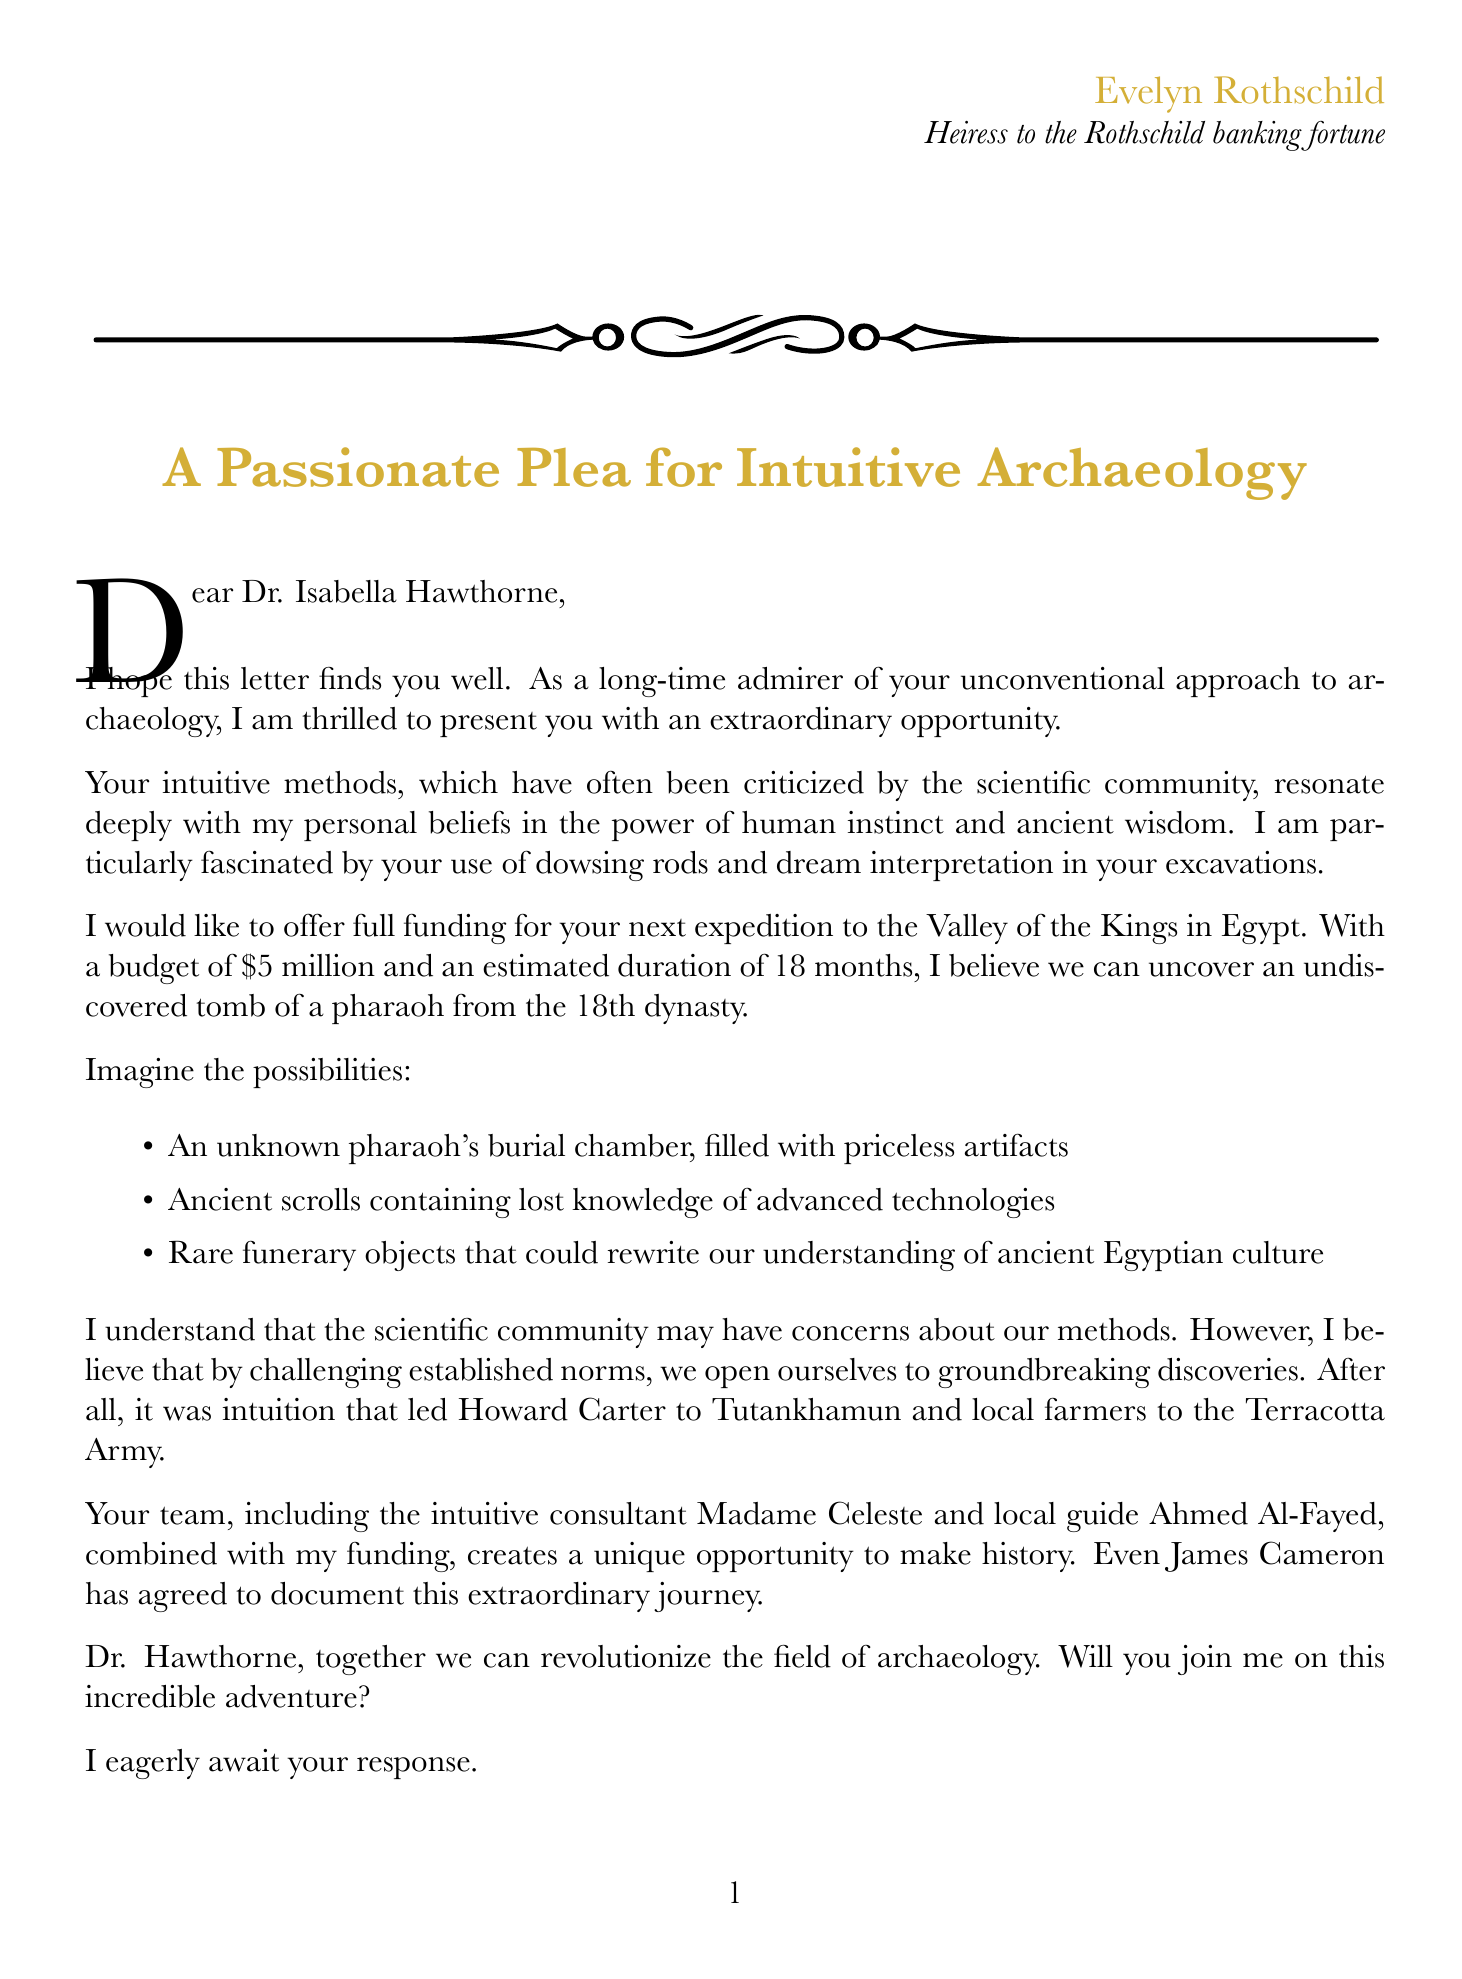what is the name of the donor? The document begins with the name of the donor, Evelyn Rothschild.
Answer: Evelyn Rothschild what is the proposed location for the expedition? The letter specifies the Valley of the Kings as the proposed location for the expedition.
Answer: Valley of the Kings, Egypt what is the budget for the expedition? The letter mentions the funding amount of $5 million for the expedition.
Answer: $5 million how long is the estimated duration of the expedition? The letter states that the estimated duration of the expedition is 18 months.
Answer: 18 months who is the lead archaeologist for the expedition? The document lists Dr. Isabella Hawthorne as the lead archaeologist for the expedition.
Answer: Dr. Isabella Hawthorne what unconventional method did Evelyn Rothschild express fascination with? The letter highlights the use of dowsing rods as an example of the unconventional methods used.
Answer: dowsing rods which famous archaeological discovery is referenced in the letter? The document mentions Howard Carter's discovery of the tomb of Tutankhamun.
Answer: tomb of Tutankhamun what is emphasized as a reason for potential criticisms? The letter acknowledges concerns about lack of peer-reviewed methodology as a reason for potential criticisms.
Answer: Lack of peer-reviewed methodology who is the local guide mentioned in the expedition team? The document provides the name of the local guide as Ahmed Al-Fayed.
Answer: Ahmed Al-Fayed 